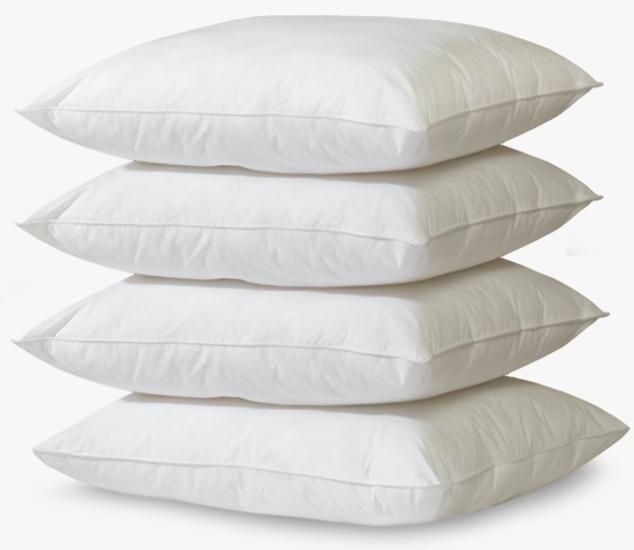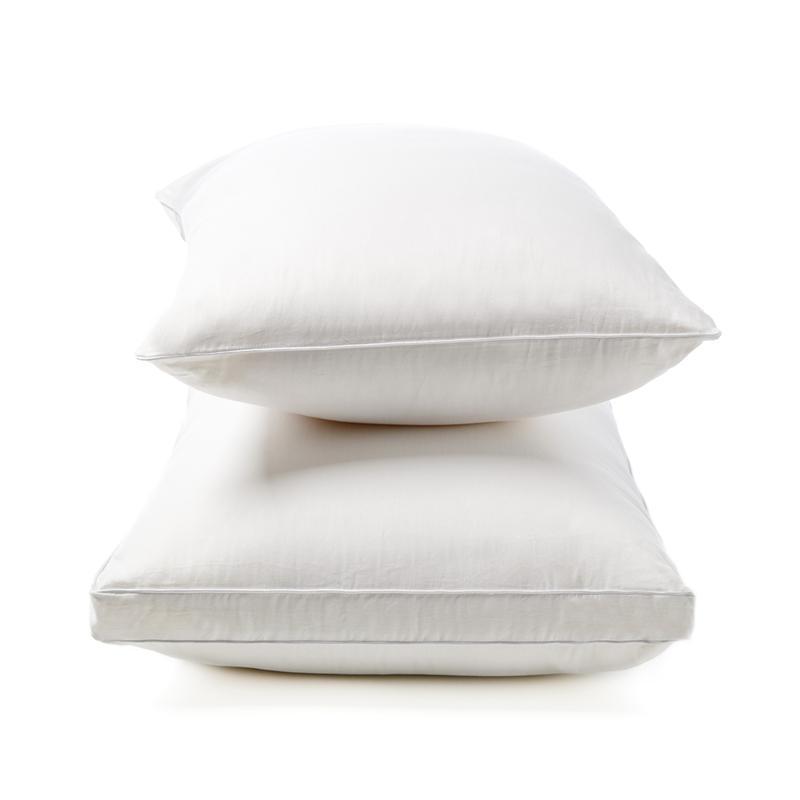The first image is the image on the left, the second image is the image on the right. For the images displayed, is the sentence "The right image contains two  white pillows stacked vertically on top of each other." factually correct? Answer yes or no. Yes. The first image is the image on the left, the second image is the image on the right. Evaluate the accuracy of this statement regarding the images: "The left image contains a stack of four pillows and the right image contains a stack of two pillows.". Is it true? Answer yes or no. Yes. 